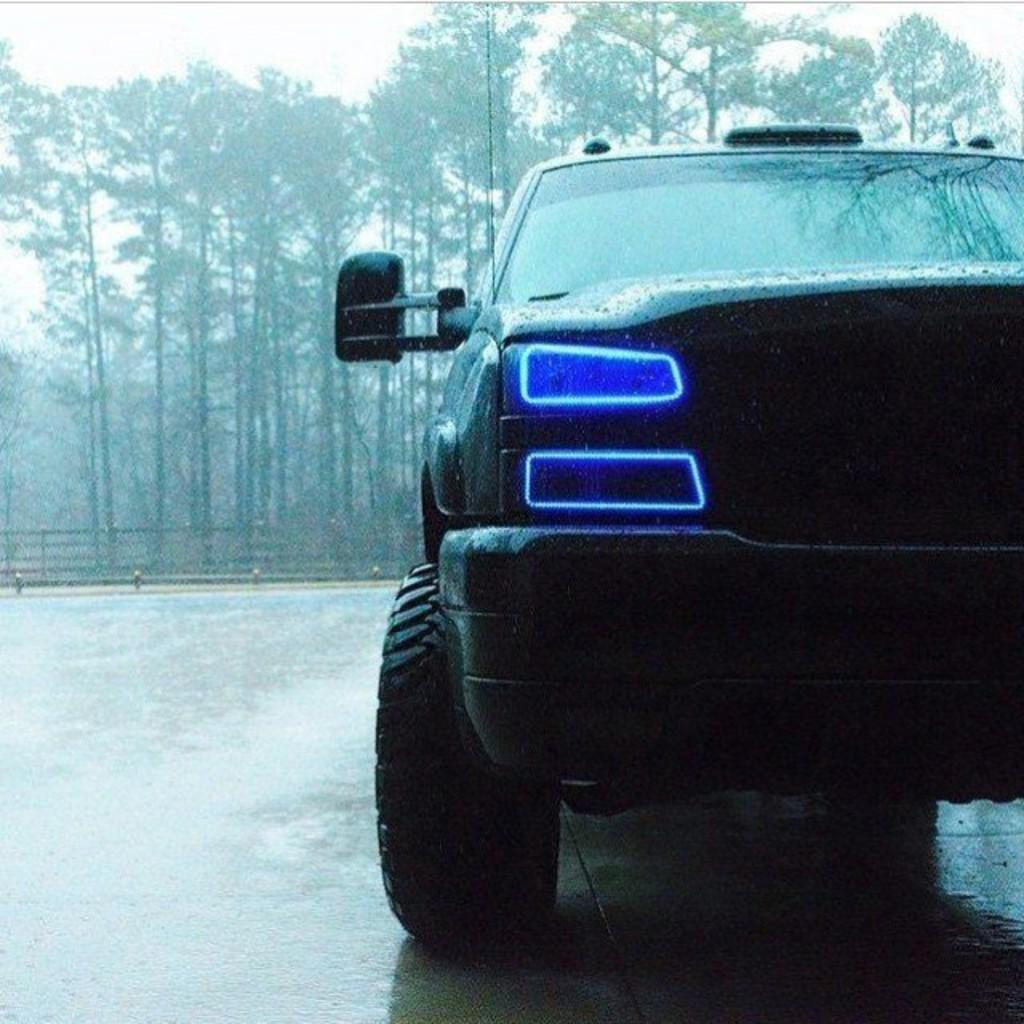What is the main subject of the image? The main subject of the image is a car. What features can be seen on the car? The car has lights. What is located behind the car? There is wooden fencing behind the car. What can be seen beyond the wooden fencing? There is a group of trees behind the wooden fencing. What is visible at the top of the image? The sky is visible at the top of the image. What type of list can be seen hanging from the car's rearview mirror in the image? There is no list present in the image; it only features a car with lights, wooden fencing, a group of trees, and the sky. What color is the string used to tie the rod to the car's roof in the image? There is no string or rod present in the image. 